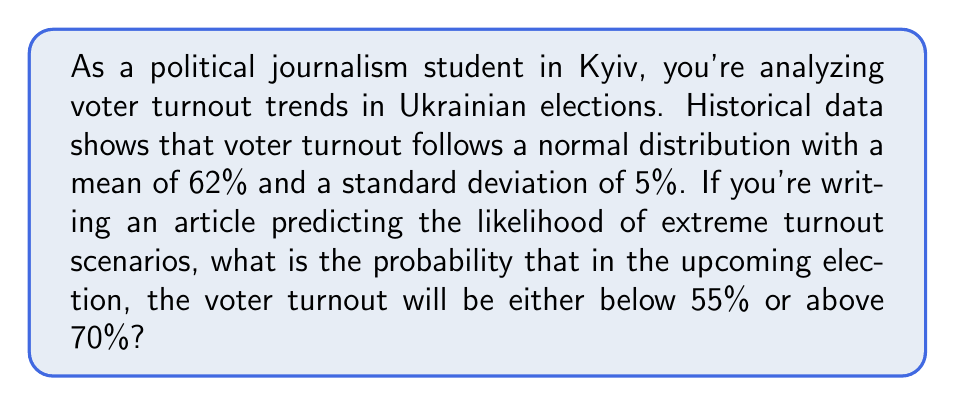Provide a solution to this math problem. Let's approach this step-by-step:

1) We're dealing with a normal distribution where:
   $\mu = 62\%$ (mean)
   $\sigma = 5\%$ (standard deviation)

2) We need to find:
   $P(X < 55\%) + P(X > 70\%)$

3) To use the standard normal distribution, we need to convert these values to z-scores:

   For 55%: $z_1 = \frac{55 - 62}{5} = -1.4$
   For 70%: $z_2 = \frac{70 - 62}{5} = 1.6$

4) Now we can rephrase our problem as:
   $P(Z < -1.4) + P(Z > 1.6)$

5) Using the standard normal distribution table or a calculator:
   $P(Z < -1.4) = 0.0808$
   $P(Z > 1.6) = 1 - P(Z < 1.6) = 1 - 0.9452 = 0.0548$

6) Adding these probabilities:
   $0.0808 + 0.0548 = 0.1356$

Therefore, the probability of voter turnout being either below 55% or above 70% is approximately 0.1356 or 13.56%.
Answer: 0.1356 (or 13.56%) 